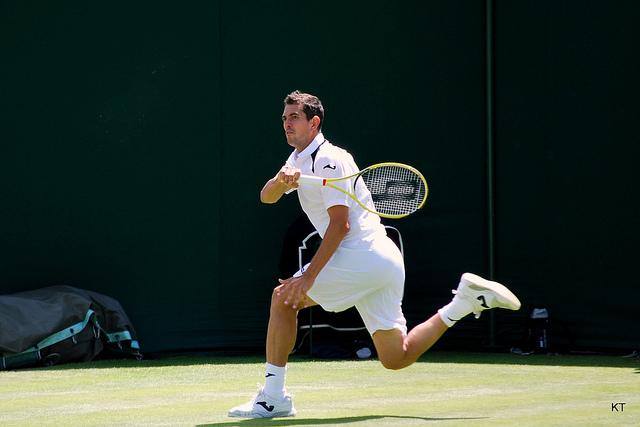What brand is his racquet?
Write a very short answer. Prince. How many hand the player use to hold the racket?
Short answer required. 1. What sport is the man doing?
Quick response, please. Tennis. Which hand is the man holding the racquet with?
Be succinct. Right. What letter is shown on the tennis racquet?
Write a very short answer. P. What is the man doing?
Quick response, please. Playing tennis. 